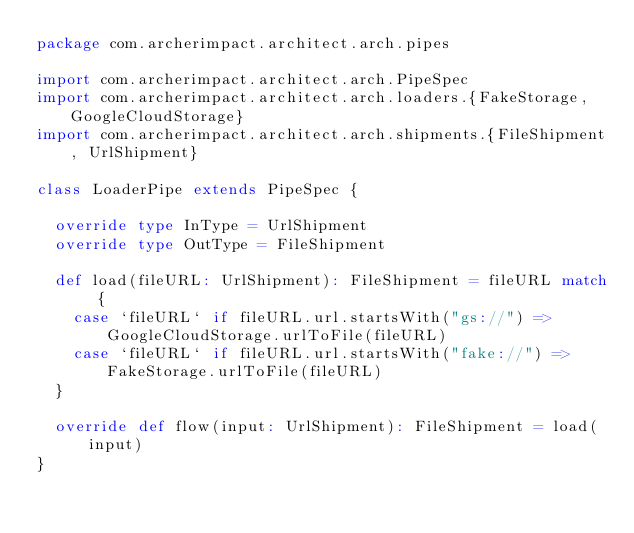Convert code to text. <code><loc_0><loc_0><loc_500><loc_500><_Scala_>package com.archerimpact.architect.arch.pipes

import com.archerimpact.architect.arch.PipeSpec
import com.archerimpact.architect.arch.loaders.{FakeStorage, GoogleCloudStorage}
import com.archerimpact.architect.arch.shipments.{FileShipment, UrlShipment}

class LoaderPipe extends PipeSpec {

  override type InType = UrlShipment
  override type OutType = FileShipment

  def load(fileURL: UrlShipment): FileShipment = fileURL match {
    case `fileURL` if fileURL.url.startsWith("gs://") => GoogleCloudStorage.urlToFile(fileURL)
    case `fileURL` if fileURL.url.startsWith("fake://") => FakeStorage.urlToFile(fileURL)
  }

  override def flow(input: UrlShipment): FileShipment = load(input)
}
</code> 